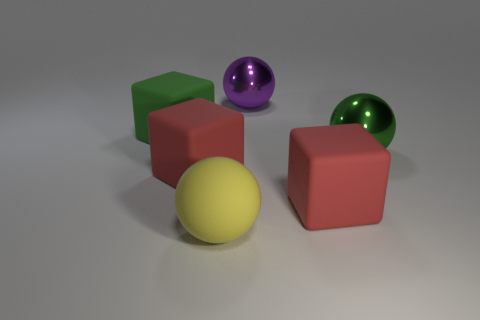Add 3 big red rubber things. How many objects exist? 9 Subtract all red cubes. How many cubes are left? 1 Subtract all rubber cubes. Subtract all small purple metallic things. How many objects are left? 3 Add 5 yellow rubber objects. How many yellow rubber objects are left? 6 Add 3 shiny balls. How many shiny balls exist? 5 Subtract all red blocks. How many blocks are left? 1 Subtract 0 cyan blocks. How many objects are left? 6 Subtract 1 blocks. How many blocks are left? 2 Subtract all brown spheres. Subtract all red cylinders. How many spheres are left? 3 Subtract all gray cubes. How many red spheres are left? 0 